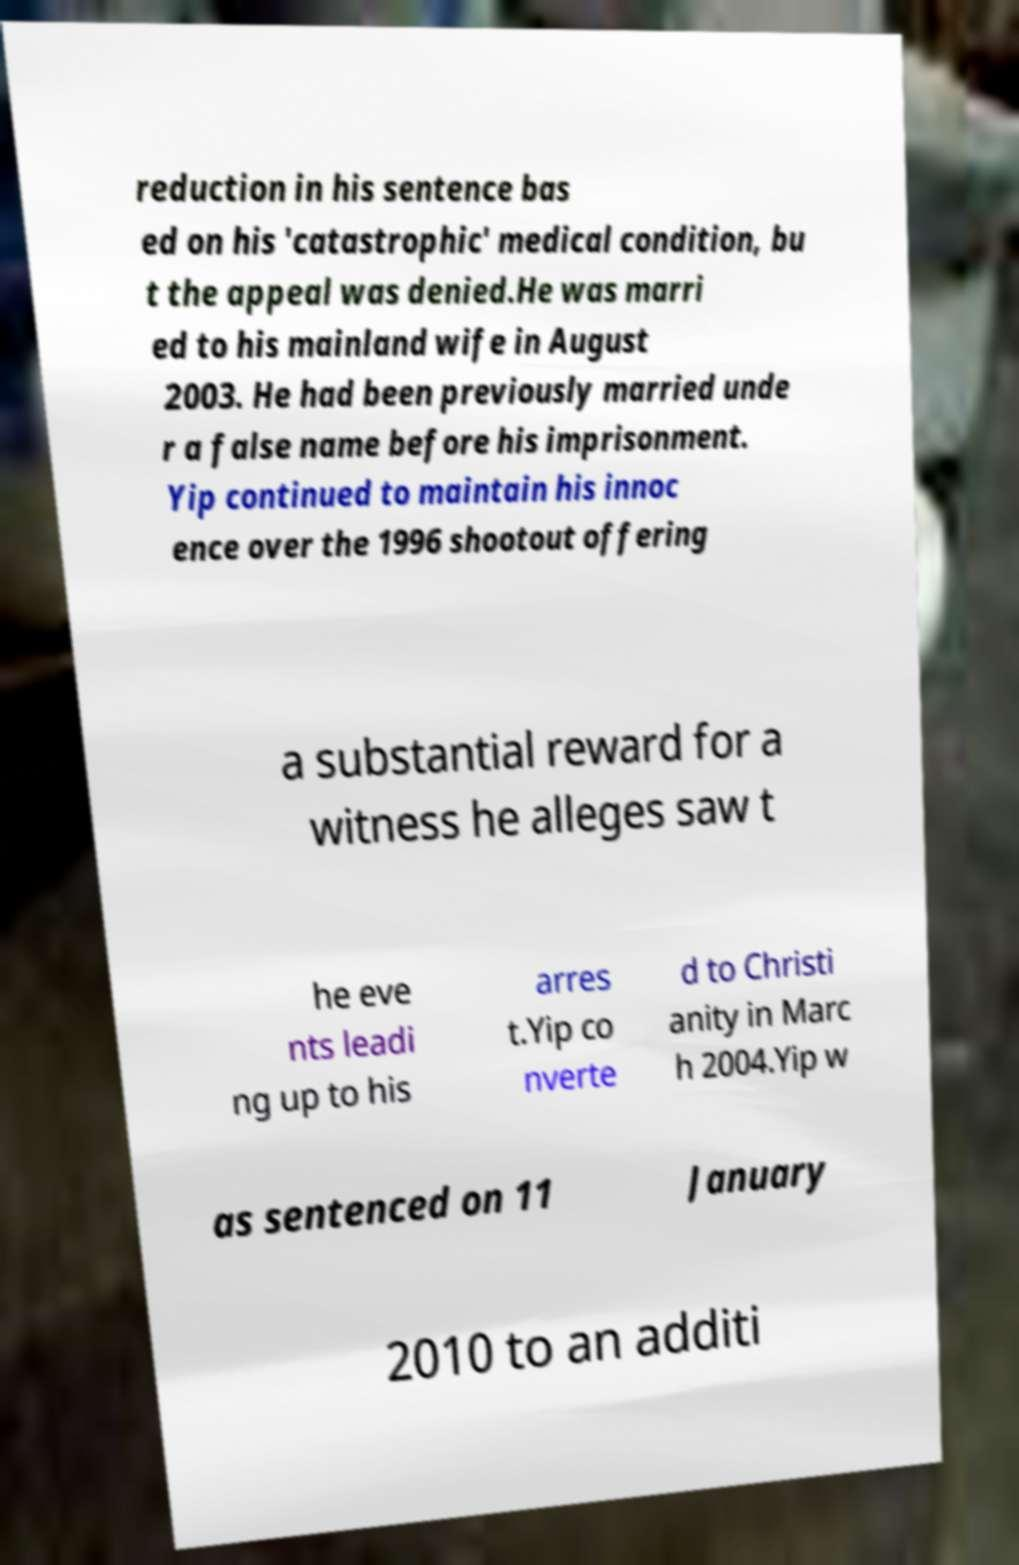There's text embedded in this image that I need extracted. Can you transcribe it verbatim? reduction in his sentence bas ed on his 'catastrophic' medical condition, bu t the appeal was denied.He was marri ed to his mainland wife in August 2003. He had been previously married unde r a false name before his imprisonment. Yip continued to maintain his innoc ence over the 1996 shootout offering a substantial reward for a witness he alleges saw t he eve nts leadi ng up to his arres t.Yip co nverte d to Christi anity in Marc h 2004.Yip w as sentenced on 11 January 2010 to an additi 